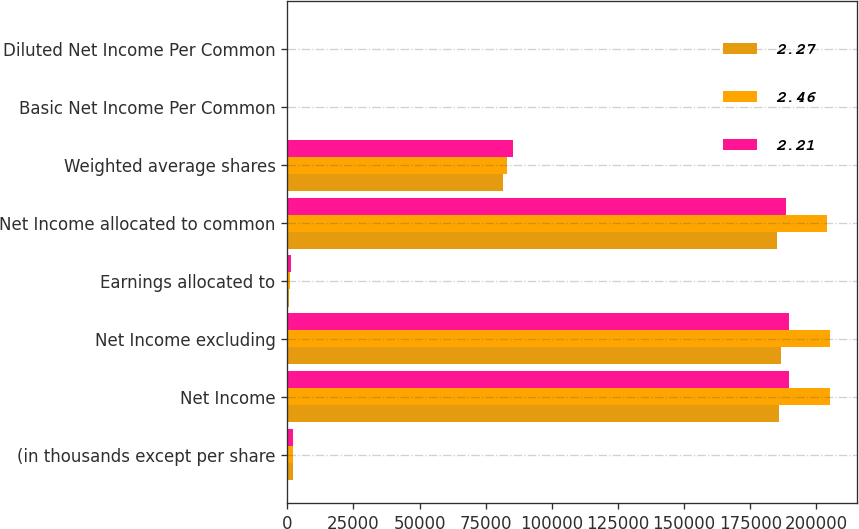Convert chart. <chart><loc_0><loc_0><loc_500><loc_500><stacked_bar_chart><ecel><fcel>(in thousands except per share<fcel>Net Income<fcel>Net Income excluding<fcel>Earnings allocated to<fcel>Net Income allocated to common<fcel>Weighted average shares<fcel>Basic Net Income Per Common<fcel>Diluted Net Income Per Common<nl><fcel>2.27<fcel>2016<fcel>185720<fcel>186820<fcel>775<fcel>184945<fcel>81432<fcel>2.27<fcel>2.27<nl><fcel>2.46<fcel>2015<fcel>205023<fcel>205023<fcel>898<fcel>204125<fcel>83081<fcel>2.46<fcel>2.46<nl><fcel>2.21<fcel>2014<fcel>189714<fcel>189714<fcel>1322<fcel>188392<fcel>85406<fcel>2.21<fcel>2.21<nl></chart> 